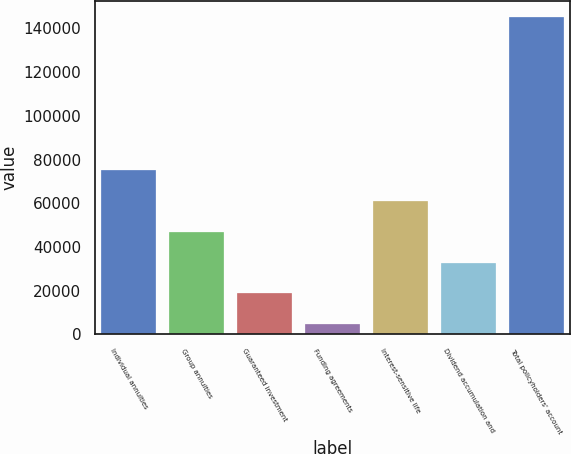Convert chart to OTSL. <chart><loc_0><loc_0><loc_500><loc_500><bar_chart><fcel>Individual annuities<fcel>Group annuities<fcel>Guaranteed investment<fcel>Funding agreements<fcel>Interest-sensitive life<fcel>Dividend accumulation and<fcel>Total policyholders' account<nl><fcel>74999.5<fcel>46917.3<fcel>18835.1<fcel>4794<fcel>60958.4<fcel>32876.2<fcel>145205<nl></chart> 